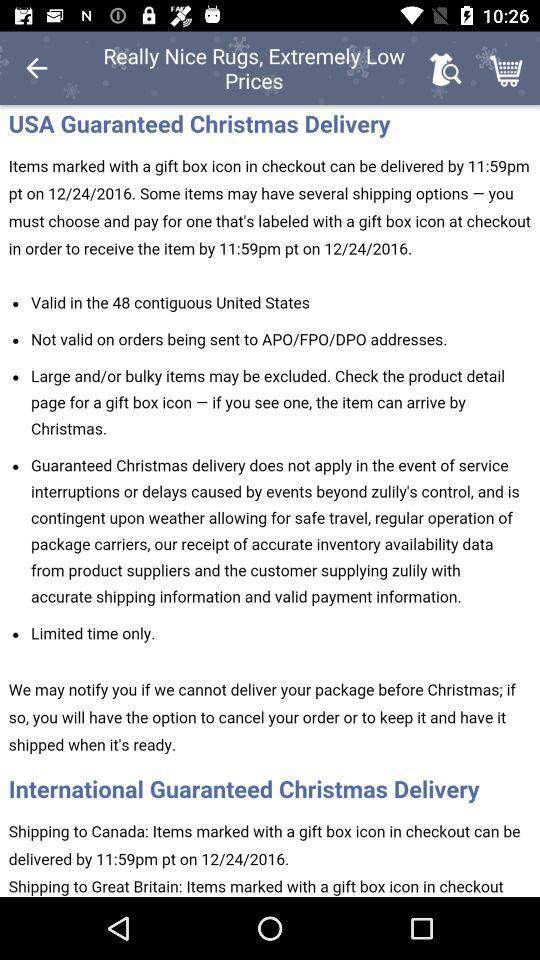How many countries are mentioned in the international guaranteed christmas delivery section?
Answer the question using a single word or phrase. 2 